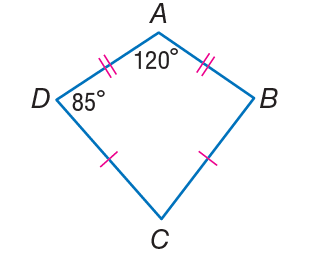Question: If A B C D is a kite. Find m \angle C.
Choices:
A. 60
B. 70
C. 85
D. 120
Answer with the letter. Answer: B 